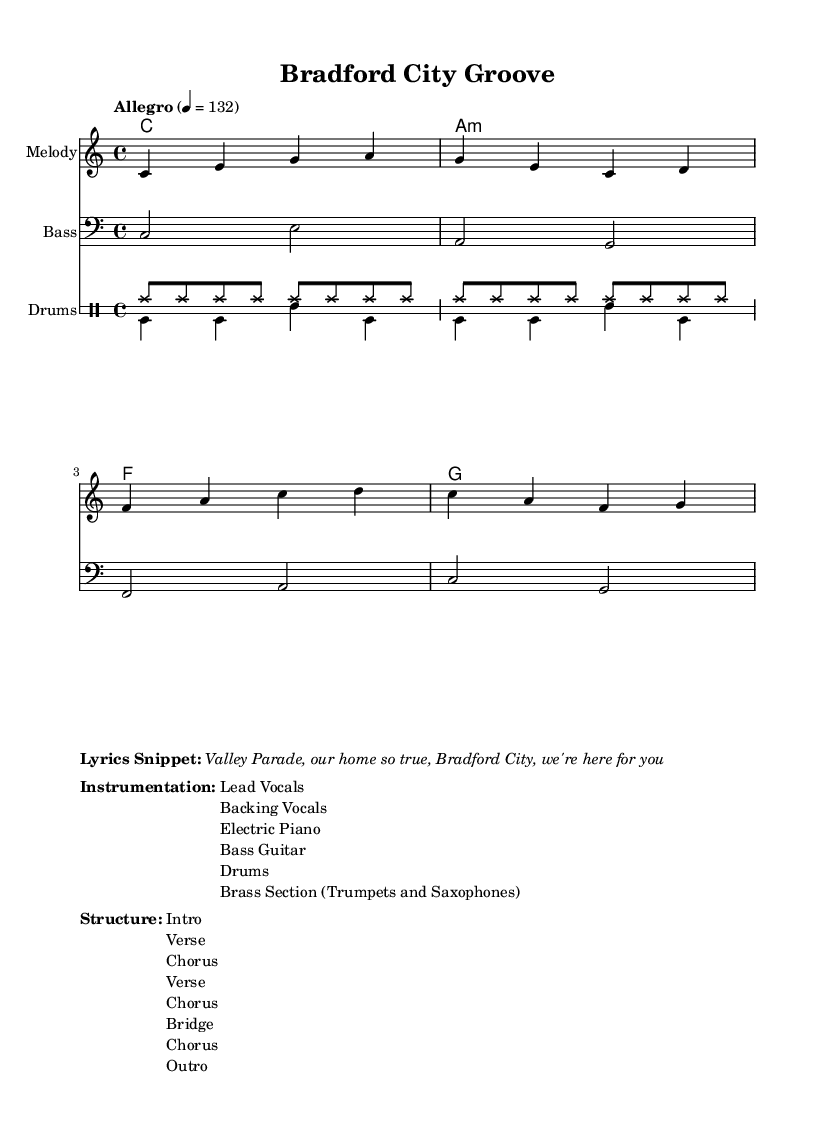What is the key signature of this music? The key signature is indicated at the beginning of the score, showing C major, which has no sharps or flats.
Answer: C major What is the time signature of this piece? The time signature is also provided at the start, showing a 4/4 time signature which indicates there are four beats in each measure.
Answer: 4/4 What tempo marking is indicated? The tempo marking suggests an Allegro pace at 132 beats per minute, which is stated at the top of the score.
Answer: Allegro, 132 How many main sections are in the structure? The structure is listed and includes eight distinct sections, which indicates how the piece is organized.
Answer: 8 What instruments are included in the instrumentation? The instrumentation is listed in the score, detailing that it features lead vocals, backing vocals, electric piano, bass guitar, drums, and horns, specifically trumpets and saxophones.
Answer: Lead Vocals, Backing Vocals, Electric Piano, Bass Guitar, Drums, Brass Section How many times does the chorus occur in this piece? By analyzing the structure, the chorus appears three times in the sequence of the song's layout.
Answer: 3 Which performance style does this music best represent? The overall setup, instrumentation, and tempo suggest that it is characteristic of Northern Soul music, which emphasizes groove and rhythm, making it a distinctive genre within soul music.
Answer: Northern Soul 